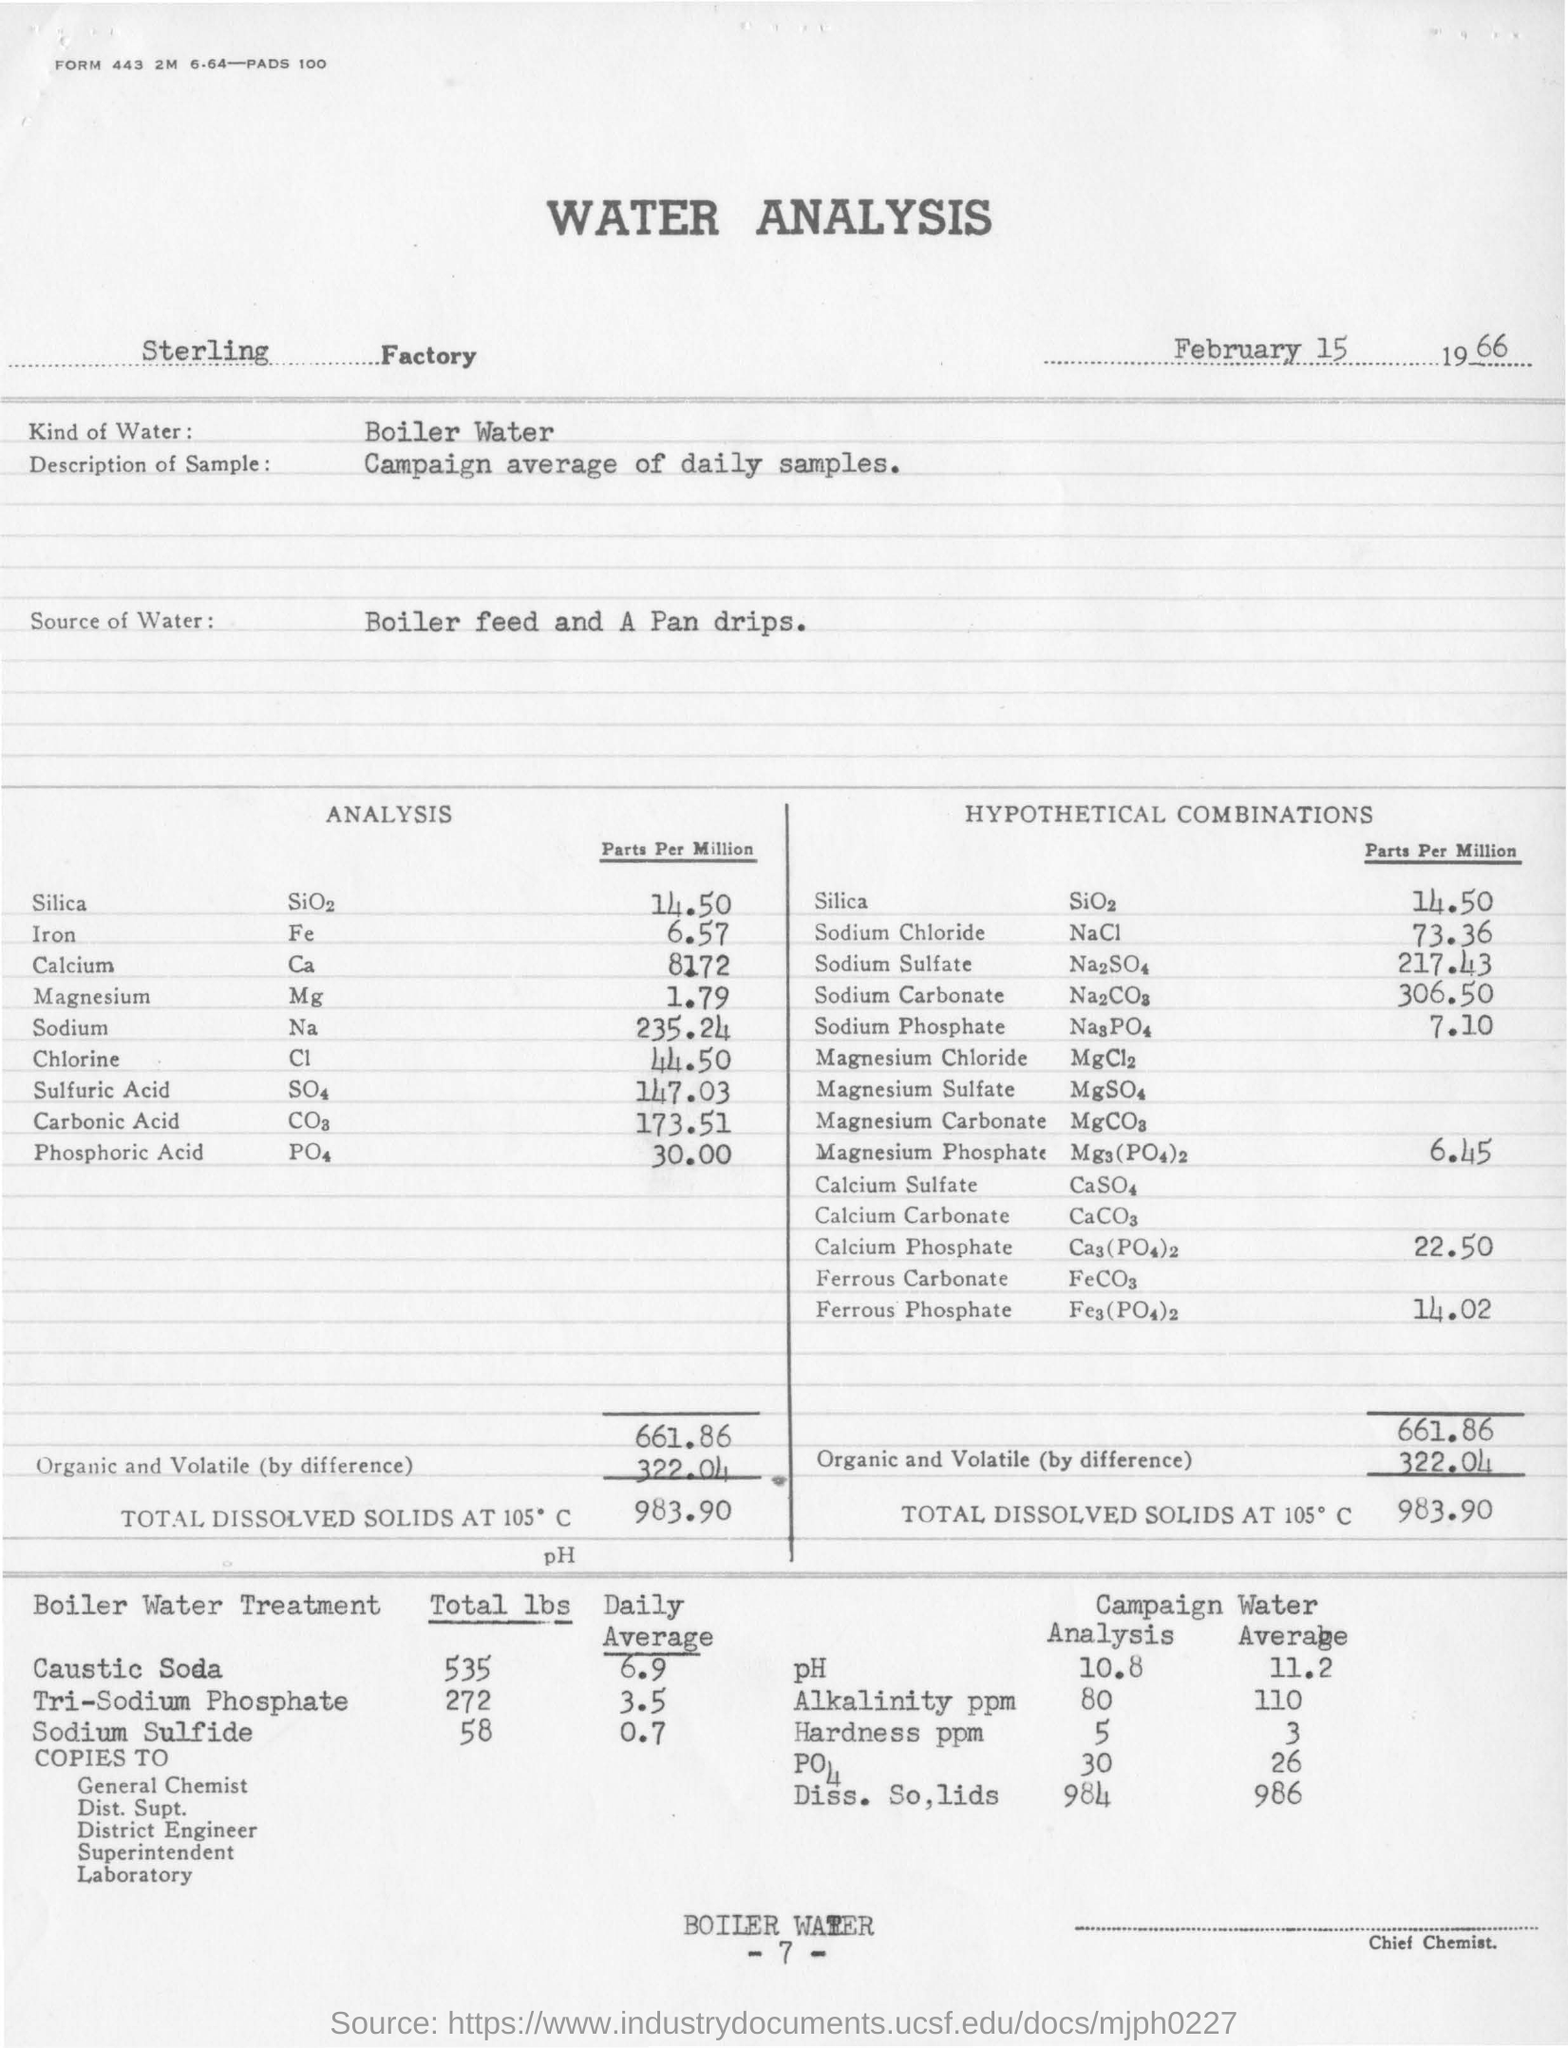Draw attention to some important aspects in this diagram. The average pH value of campaign water is 11.2. The total amount of caustic soda used in boiler water treatment is 535 pounds. The average value of sodium sulfide used in boiler water treatment is approximately 0.7. The name of the factory is Sterling Water. The analysis presented in this document was conducted on February 15, 1966. 